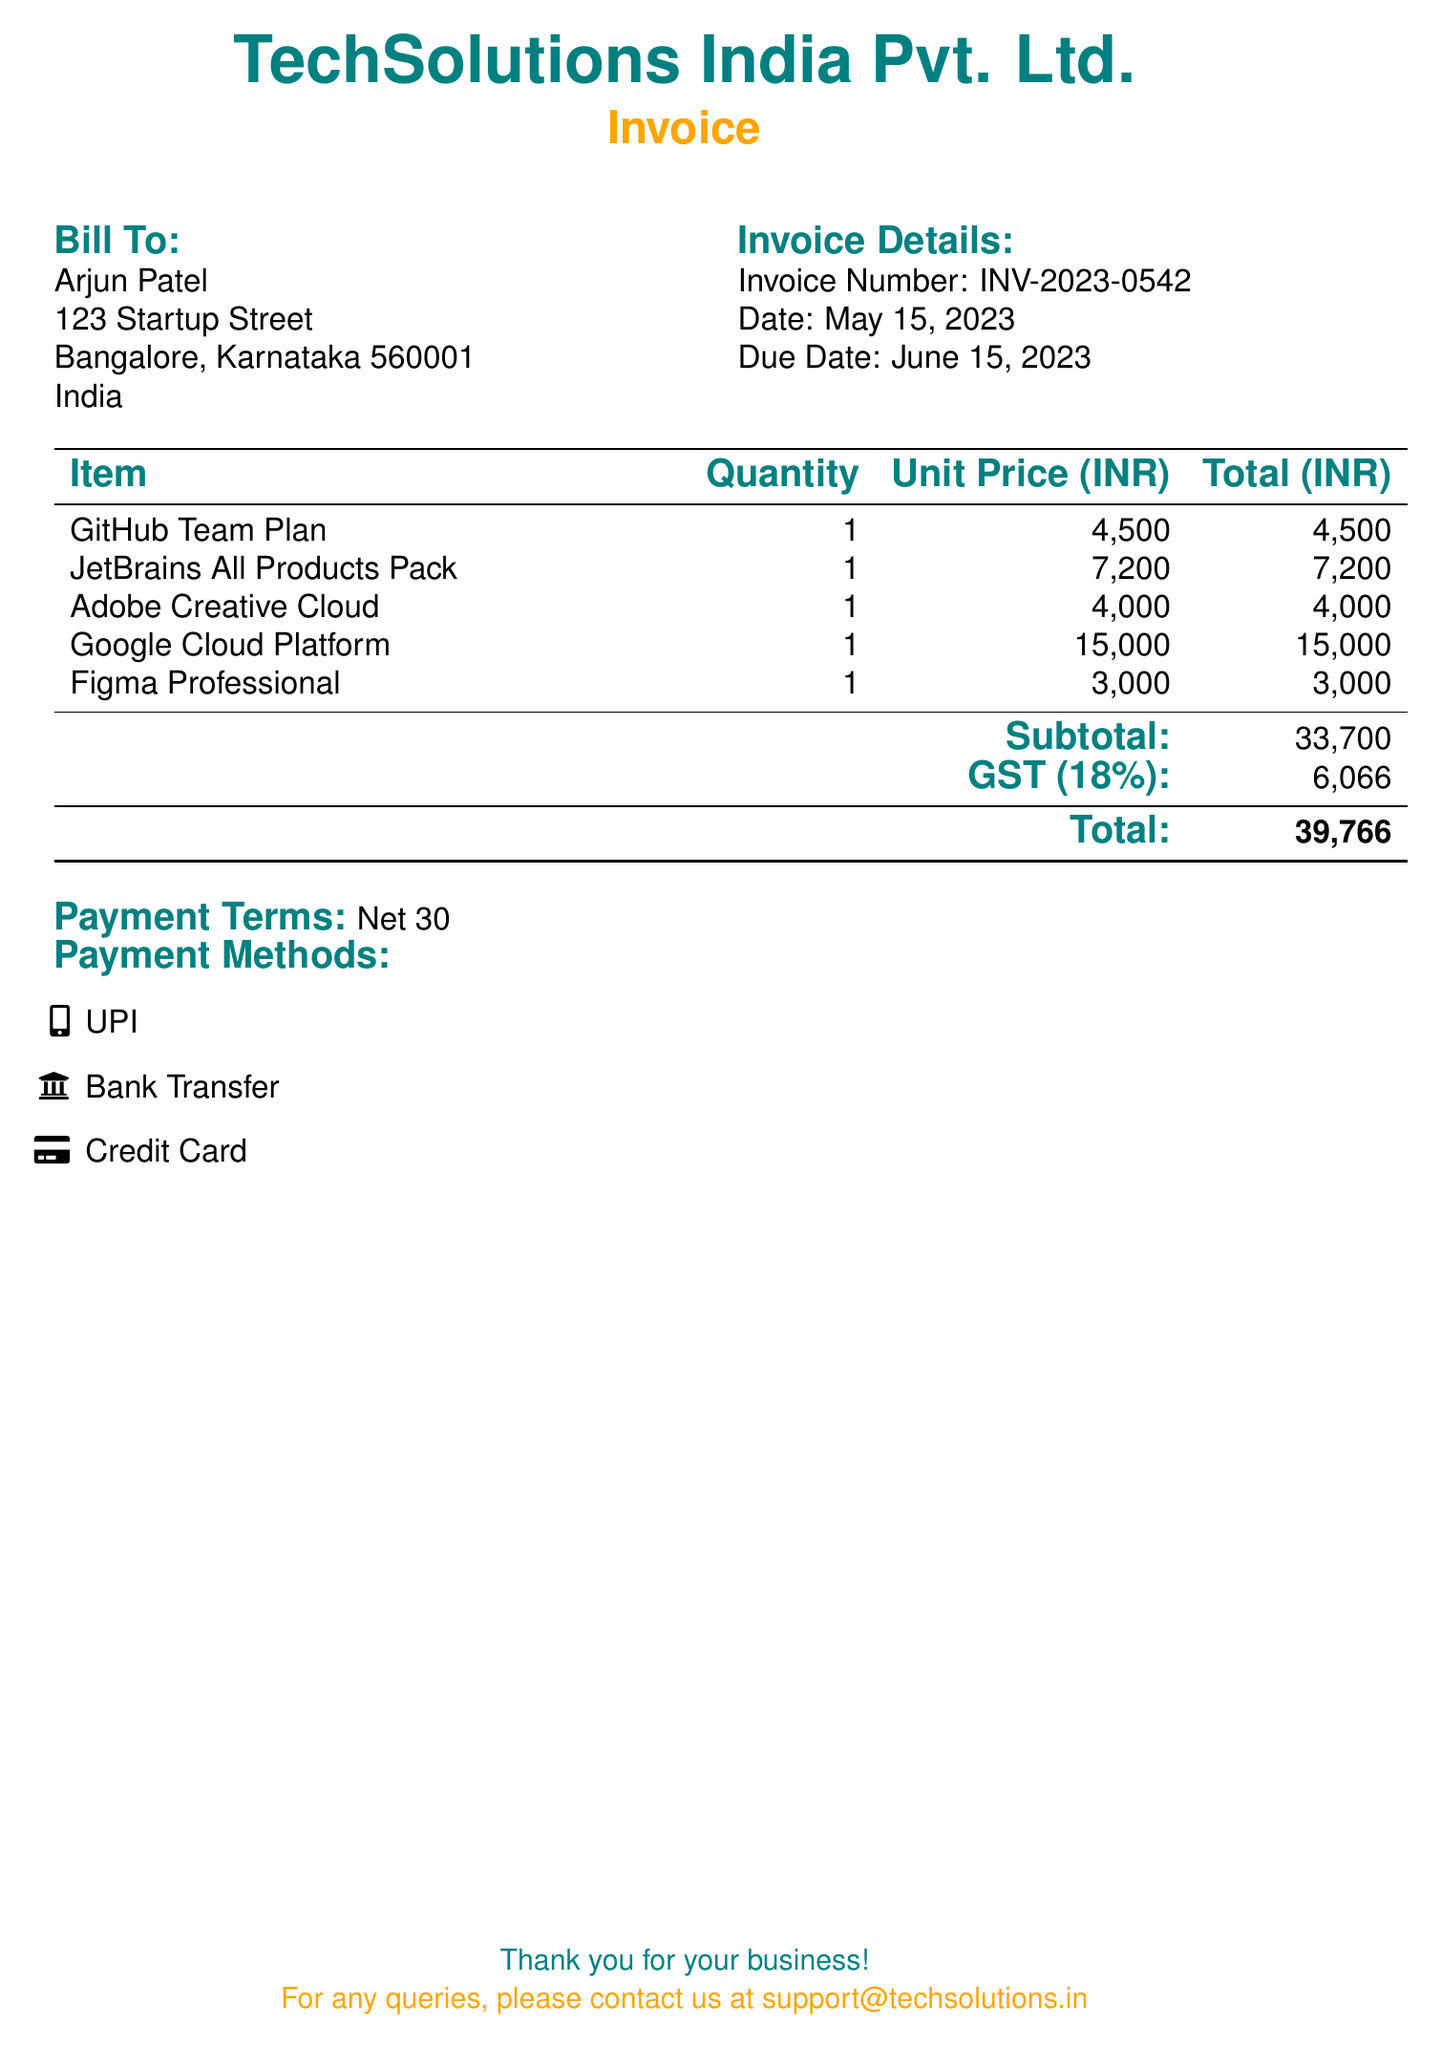What is the invoice number? The invoice number is clearly stated in the document as "INV-2023-0542."
Answer: INV-2023-0542 Who is the bill addressed to? The bill is addressed to "Arjun Patel," as mentioned in the "Bill To" section.
Answer: Arjun Patel What is the subtotal amount? The subtotal amount is indicated in the document as 33,700.
Answer: 33,700 What is the due date for the invoice? The due date for payment is specified as June 15, 2023.
Answer: June 15, 2023 How much is the GST charged? The GST amount in the document is stated as 6,066.
Answer: 6,066 What payment terms are listed? The payment terms mentioned in the document are "Net 30."
Answer: Net 30 Which software tool has the highest charge? The highest charge among the software tools listed is for "Google Cloud Platform," which costs 15,000.
Answer: Google Cloud Platform How many items are listed in the invoice? The invoice lists a total of five different software tools or items.
Answer: 5 What is the total amount due? The total amount due is stated at the bottom of the bill as 39,766.
Answer: 39,766 